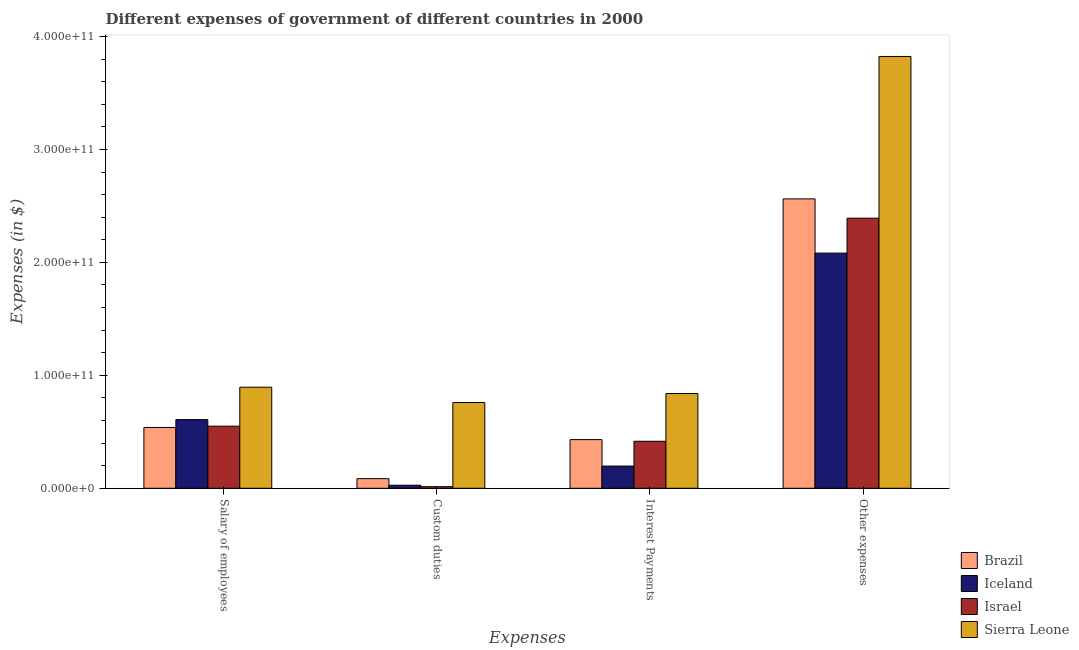How many different coloured bars are there?
Your answer should be very brief. 4. Are the number of bars per tick equal to the number of legend labels?
Ensure brevity in your answer.  Yes. How many bars are there on the 3rd tick from the right?
Make the answer very short. 4. What is the label of the 4th group of bars from the left?
Offer a very short reply. Other expenses. What is the amount spent on other expenses in Brazil?
Give a very brief answer. 2.56e+11. Across all countries, what is the maximum amount spent on custom duties?
Give a very brief answer. 7.59e+1. Across all countries, what is the minimum amount spent on other expenses?
Provide a short and direct response. 2.08e+11. In which country was the amount spent on custom duties maximum?
Ensure brevity in your answer.  Sierra Leone. In which country was the amount spent on other expenses minimum?
Your answer should be very brief. Iceland. What is the total amount spent on interest payments in the graph?
Keep it short and to the point. 1.88e+11. What is the difference between the amount spent on salary of employees in Sierra Leone and that in Israel?
Your answer should be very brief. 3.45e+1. What is the difference between the amount spent on custom duties in Iceland and the amount spent on other expenses in Brazil?
Ensure brevity in your answer.  -2.54e+11. What is the average amount spent on custom duties per country?
Provide a succinct answer. 2.21e+1. What is the difference between the amount spent on interest payments and amount spent on custom duties in Israel?
Offer a terse response. 4.02e+1. In how many countries, is the amount spent on salary of employees greater than 200000000000 $?
Offer a very short reply. 0. What is the ratio of the amount spent on other expenses in Brazil to that in Israel?
Give a very brief answer. 1.07. Is the difference between the amount spent on interest payments in Israel and Iceland greater than the difference between the amount spent on salary of employees in Israel and Iceland?
Your answer should be very brief. Yes. What is the difference between the highest and the second highest amount spent on other expenses?
Give a very brief answer. 1.26e+11. What is the difference between the highest and the lowest amount spent on interest payments?
Offer a very short reply. 6.42e+1. In how many countries, is the amount spent on other expenses greater than the average amount spent on other expenses taken over all countries?
Keep it short and to the point. 1. Is it the case that in every country, the sum of the amount spent on custom duties and amount spent on salary of employees is greater than the sum of amount spent on other expenses and amount spent on interest payments?
Offer a terse response. No. What does the 4th bar from the left in Other expenses represents?
Your response must be concise. Sierra Leone. What does the 1st bar from the right in Interest Payments represents?
Provide a short and direct response. Sierra Leone. How many bars are there?
Provide a succinct answer. 16. What is the difference between two consecutive major ticks on the Y-axis?
Provide a short and direct response. 1.00e+11. Are the values on the major ticks of Y-axis written in scientific E-notation?
Provide a short and direct response. Yes. What is the title of the graph?
Your answer should be very brief. Different expenses of government of different countries in 2000. Does "Hungary" appear as one of the legend labels in the graph?
Offer a terse response. No. What is the label or title of the X-axis?
Provide a succinct answer. Expenses. What is the label or title of the Y-axis?
Your answer should be compact. Expenses (in $). What is the Expenses (in $) in Brazil in Salary of employees?
Ensure brevity in your answer.  5.39e+1. What is the Expenses (in $) of Iceland in Salary of employees?
Your answer should be compact. 6.08e+1. What is the Expenses (in $) in Israel in Salary of employees?
Your answer should be very brief. 5.50e+1. What is the Expenses (in $) in Sierra Leone in Salary of employees?
Offer a terse response. 8.95e+1. What is the Expenses (in $) in Brazil in Custom duties?
Your answer should be compact. 8.51e+09. What is the Expenses (in $) in Iceland in Custom duties?
Your answer should be compact. 2.70e+09. What is the Expenses (in $) in Israel in Custom duties?
Your answer should be compact. 1.42e+09. What is the Expenses (in $) in Sierra Leone in Custom duties?
Give a very brief answer. 7.59e+1. What is the Expenses (in $) in Brazil in Interest Payments?
Offer a very short reply. 4.31e+1. What is the Expenses (in $) in Iceland in Interest Payments?
Offer a very short reply. 1.97e+1. What is the Expenses (in $) in Israel in Interest Payments?
Your response must be concise. 4.16e+1. What is the Expenses (in $) of Sierra Leone in Interest Payments?
Offer a terse response. 8.39e+1. What is the Expenses (in $) in Brazil in Other expenses?
Your answer should be very brief. 2.56e+11. What is the Expenses (in $) in Iceland in Other expenses?
Give a very brief answer. 2.08e+11. What is the Expenses (in $) in Israel in Other expenses?
Give a very brief answer. 2.39e+11. What is the Expenses (in $) of Sierra Leone in Other expenses?
Your answer should be very brief. 3.82e+11. Across all Expenses, what is the maximum Expenses (in $) of Brazil?
Your response must be concise. 2.56e+11. Across all Expenses, what is the maximum Expenses (in $) in Iceland?
Provide a short and direct response. 2.08e+11. Across all Expenses, what is the maximum Expenses (in $) of Israel?
Your answer should be compact. 2.39e+11. Across all Expenses, what is the maximum Expenses (in $) of Sierra Leone?
Give a very brief answer. 3.82e+11. Across all Expenses, what is the minimum Expenses (in $) in Brazil?
Ensure brevity in your answer.  8.51e+09. Across all Expenses, what is the minimum Expenses (in $) of Iceland?
Your answer should be very brief. 2.70e+09. Across all Expenses, what is the minimum Expenses (in $) of Israel?
Offer a terse response. 1.42e+09. Across all Expenses, what is the minimum Expenses (in $) in Sierra Leone?
Your answer should be very brief. 7.59e+1. What is the total Expenses (in $) of Brazil in the graph?
Ensure brevity in your answer.  3.62e+11. What is the total Expenses (in $) of Iceland in the graph?
Give a very brief answer. 2.91e+11. What is the total Expenses (in $) of Israel in the graph?
Provide a succinct answer. 3.37e+11. What is the total Expenses (in $) in Sierra Leone in the graph?
Your response must be concise. 6.32e+11. What is the difference between the Expenses (in $) in Brazil in Salary of employees and that in Custom duties?
Offer a very short reply. 4.53e+1. What is the difference between the Expenses (in $) in Iceland in Salary of employees and that in Custom duties?
Provide a succinct answer. 5.81e+1. What is the difference between the Expenses (in $) of Israel in Salary of employees and that in Custom duties?
Offer a very short reply. 5.36e+1. What is the difference between the Expenses (in $) of Sierra Leone in Salary of employees and that in Custom duties?
Ensure brevity in your answer.  1.36e+1. What is the difference between the Expenses (in $) in Brazil in Salary of employees and that in Interest Payments?
Provide a short and direct response. 1.08e+1. What is the difference between the Expenses (in $) in Iceland in Salary of employees and that in Interest Payments?
Make the answer very short. 4.11e+1. What is the difference between the Expenses (in $) in Israel in Salary of employees and that in Interest Payments?
Make the answer very short. 1.34e+1. What is the difference between the Expenses (in $) in Sierra Leone in Salary of employees and that in Interest Payments?
Provide a short and direct response. 5.58e+09. What is the difference between the Expenses (in $) in Brazil in Salary of employees and that in Other expenses?
Keep it short and to the point. -2.02e+11. What is the difference between the Expenses (in $) in Iceland in Salary of employees and that in Other expenses?
Give a very brief answer. -1.47e+11. What is the difference between the Expenses (in $) in Israel in Salary of employees and that in Other expenses?
Offer a terse response. -1.84e+11. What is the difference between the Expenses (in $) in Sierra Leone in Salary of employees and that in Other expenses?
Provide a succinct answer. -2.93e+11. What is the difference between the Expenses (in $) of Brazil in Custom duties and that in Interest Payments?
Make the answer very short. -3.46e+1. What is the difference between the Expenses (in $) of Iceland in Custom duties and that in Interest Payments?
Make the answer very short. -1.70e+1. What is the difference between the Expenses (in $) of Israel in Custom duties and that in Interest Payments?
Provide a short and direct response. -4.02e+1. What is the difference between the Expenses (in $) in Sierra Leone in Custom duties and that in Interest Payments?
Your response must be concise. -8.00e+09. What is the difference between the Expenses (in $) in Brazil in Custom duties and that in Other expenses?
Your answer should be very brief. -2.48e+11. What is the difference between the Expenses (in $) in Iceland in Custom duties and that in Other expenses?
Make the answer very short. -2.06e+11. What is the difference between the Expenses (in $) of Israel in Custom duties and that in Other expenses?
Offer a very short reply. -2.38e+11. What is the difference between the Expenses (in $) of Sierra Leone in Custom duties and that in Other expenses?
Give a very brief answer. -3.06e+11. What is the difference between the Expenses (in $) of Brazil in Interest Payments and that in Other expenses?
Provide a short and direct response. -2.13e+11. What is the difference between the Expenses (in $) in Iceland in Interest Payments and that in Other expenses?
Provide a succinct answer. -1.89e+11. What is the difference between the Expenses (in $) of Israel in Interest Payments and that in Other expenses?
Provide a succinct answer. -1.98e+11. What is the difference between the Expenses (in $) of Sierra Leone in Interest Payments and that in Other expenses?
Your response must be concise. -2.98e+11. What is the difference between the Expenses (in $) in Brazil in Salary of employees and the Expenses (in $) in Iceland in Custom duties?
Offer a terse response. 5.12e+1. What is the difference between the Expenses (in $) in Brazil in Salary of employees and the Expenses (in $) in Israel in Custom duties?
Keep it short and to the point. 5.24e+1. What is the difference between the Expenses (in $) of Brazil in Salary of employees and the Expenses (in $) of Sierra Leone in Custom duties?
Give a very brief answer. -2.21e+1. What is the difference between the Expenses (in $) of Iceland in Salary of employees and the Expenses (in $) of Israel in Custom duties?
Keep it short and to the point. 5.94e+1. What is the difference between the Expenses (in $) in Iceland in Salary of employees and the Expenses (in $) in Sierra Leone in Custom duties?
Make the answer very short. -1.51e+1. What is the difference between the Expenses (in $) of Israel in Salary of employees and the Expenses (in $) of Sierra Leone in Custom duties?
Your answer should be compact. -2.09e+1. What is the difference between the Expenses (in $) of Brazil in Salary of employees and the Expenses (in $) of Iceland in Interest Payments?
Offer a very short reply. 3.42e+1. What is the difference between the Expenses (in $) of Brazil in Salary of employees and the Expenses (in $) of Israel in Interest Payments?
Offer a very short reply. 1.22e+1. What is the difference between the Expenses (in $) in Brazil in Salary of employees and the Expenses (in $) in Sierra Leone in Interest Payments?
Keep it short and to the point. -3.01e+1. What is the difference between the Expenses (in $) in Iceland in Salary of employees and the Expenses (in $) in Israel in Interest Payments?
Your answer should be very brief. 1.92e+1. What is the difference between the Expenses (in $) of Iceland in Salary of employees and the Expenses (in $) of Sierra Leone in Interest Payments?
Offer a very short reply. -2.31e+1. What is the difference between the Expenses (in $) in Israel in Salary of employees and the Expenses (in $) in Sierra Leone in Interest Payments?
Make the answer very short. -2.89e+1. What is the difference between the Expenses (in $) in Brazil in Salary of employees and the Expenses (in $) in Iceland in Other expenses?
Give a very brief answer. -1.54e+11. What is the difference between the Expenses (in $) of Brazil in Salary of employees and the Expenses (in $) of Israel in Other expenses?
Make the answer very short. -1.85e+11. What is the difference between the Expenses (in $) in Brazil in Salary of employees and the Expenses (in $) in Sierra Leone in Other expenses?
Offer a very short reply. -3.28e+11. What is the difference between the Expenses (in $) in Iceland in Salary of employees and the Expenses (in $) in Israel in Other expenses?
Provide a short and direct response. -1.78e+11. What is the difference between the Expenses (in $) of Iceland in Salary of employees and the Expenses (in $) of Sierra Leone in Other expenses?
Your response must be concise. -3.22e+11. What is the difference between the Expenses (in $) of Israel in Salary of employees and the Expenses (in $) of Sierra Leone in Other expenses?
Make the answer very short. -3.27e+11. What is the difference between the Expenses (in $) in Brazil in Custom duties and the Expenses (in $) in Iceland in Interest Payments?
Give a very brief answer. -1.12e+1. What is the difference between the Expenses (in $) in Brazil in Custom duties and the Expenses (in $) in Israel in Interest Payments?
Offer a terse response. -3.31e+1. What is the difference between the Expenses (in $) of Brazil in Custom duties and the Expenses (in $) of Sierra Leone in Interest Payments?
Keep it short and to the point. -7.54e+1. What is the difference between the Expenses (in $) of Iceland in Custom duties and the Expenses (in $) of Israel in Interest Payments?
Ensure brevity in your answer.  -3.89e+1. What is the difference between the Expenses (in $) of Iceland in Custom duties and the Expenses (in $) of Sierra Leone in Interest Payments?
Your answer should be very brief. -8.12e+1. What is the difference between the Expenses (in $) in Israel in Custom duties and the Expenses (in $) in Sierra Leone in Interest Payments?
Your response must be concise. -8.25e+1. What is the difference between the Expenses (in $) in Brazil in Custom duties and the Expenses (in $) in Iceland in Other expenses?
Your answer should be compact. -2.00e+11. What is the difference between the Expenses (in $) of Brazil in Custom duties and the Expenses (in $) of Israel in Other expenses?
Your answer should be very brief. -2.31e+11. What is the difference between the Expenses (in $) in Brazil in Custom duties and the Expenses (in $) in Sierra Leone in Other expenses?
Provide a short and direct response. -3.74e+11. What is the difference between the Expenses (in $) of Iceland in Custom duties and the Expenses (in $) of Israel in Other expenses?
Offer a very short reply. -2.36e+11. What is the difference between the Expenses (in $) of Iceland in Custom duties and the Expenses (in $) of Sierra Leone in Other expenses?
Your answer should be very brief. -3.80e+11. What is the difference between the Expenses (in $) in Israel in Custom duties and the Expenses (in $) in Sierra Leone in Other expenses?
Give a very brief answer. -3.81e+11. What is the difference between the Expenses (in $) in Brazil in Interest Payments and the Expenses (in $) in Iceland in Other expenses?
Your answer should be very brief. -1.65e+11. What is the difference between the Expenses (in $) of Brazil in Interest Payments and the Expenses (in $) of Israel in Other expenses?
Your response must be concise. -1.96e+11. What is the difference between the Expenses (in $) in Brazil in Interest Payments and the Expenses (in $) in Sierra Leone in Other expenses?
Offer a terse response. -3.39e+11. What is the difference between the Expenses (in $) in Iceland in Interest Payments and the Expenses (in $) in Israel in Other expenses?
Provide a short and direct response. -2.19e+11. What is the difference between the Expenses (in $) in Iceland in Interest Payments and the Expenses (in $) in Sierra Leone in Other expenses?
Give a very brief answer. -3.63e+11. What is the difference between the Expenses (in $) in Israel in Interest Payments and the Expenses (in $) in Sierra Leone in Other expenses?
Ensure brevity in your answer.  -3.41e+11. What is the average Expenses (in $) of Brazil per Expenses?
Your answer should be very brief. 9.04e+1. What is the average Expenses (in $) in Iceland per Expenses?
Give a very brief answer. 7.28e+1. What is the average Expenses (in $) of Israel per Expenses?
Your response must be concise. 8.43e+1. What is the average Expenses (in $) in Sierra Leone per Expenses?
Ensure brevity in your answer.  1.58e+11. What is the difference between the Expenses (in $) of Brazil and Expenses (in $) of Iceland in Salary of employees?
Make the answer very short. -6.95e+09. What is the difference between the Expenses (in $) of Brazil and Expenses (in $) of Israel in Salary of employees?
Your answer should be very brief. -1.14e+09. What is the difference between the Expenses (in $) of Brazil and Expenses (in $) of Sierra Leone in Salary of employees?
Give a very brief answer. -3.56e+1. What is the difference between the Expenses (in $) in Iceland and Expenses (in $) in Israel in Salary of employees?
Offer a very short reply. 5.81e+09. What is the difference between the Expenses (in $) in Iceland and Expenses (in $) in Sierra Leone in Salary of employees?
Your answer should be very brief. -2.87e+1. What is the difference between the Expenses (in $) of Israel and Expenses (in $) of Sierra Leone in Salary of employees?
Offer a terse response. -3.45e+1. What is the difference between the Expenses (in $) of Brazil and Expenses (in $) of Iceland in Custom duties?
Offer a very short reply. 5.81e+09. What is the difference between the Expenses (in $) in Brazil and Expenses (in $) in Israel in Custom duties?
Provide a short and direct response. 7.09e+09. What is the difference between the Expenses (in $) in Brazil and Expenses (in $) in Sierra Leone in Custom duties?
Give a very brief answer. -6.74e+1. What is the difference between the Expenses (in $) in Iceland and Expenses (in $) in Israel in Custom duties?
Offer a terse response. 1.28e+09. What is the difference between the Expenses (in $) of Iceland and Expenses (in $) of Sierra Leone in Custom duties?
Give a very brief answer. -7.32e+1. What is the difference between the Expenses (in $) in Israel and Expenses (in $) in Sierra Leone in Custom duties?
Your response must be concise. -7.45e+1. What is the difference between the Expenses (in $) of Brazil and Expenses (in $) of Iceland in Interest Payments?
Your answer should be very brief. 2.34e+1. What is the difference between the Expenses (in $) of Brazil and Expenses (in $) of Israel in Interest Payments?
Your response must be concise. 1.47e+09. What is the difference between the Expenses (in $) of Brazil and Expenses (in $) of Sierra Leone in Interest Payments?
Provide a succinct answer. -4.08e+1. What is the difference between the Expenses (in $) in Iceland and Expenses (in $) in Israel in Interest Payments?
Keep it short and to the point. -2.20e+1. What is the difference between the Expenses (in $) in Iceland and Expenses (in $) in Sierra Leone in Interest Payments?
Provide a succinct answer. -6.42e+1. What is the difference between the Expenses (in $) in Israel and Expenses (in $) in Sierra Leone in Interest Payments?
Your answer should be very brief. -4.23e+1. What is the difference between the Expenses (in $) in Brazil and Expenses (in $) in Iceland in Other expenses?
Provide a short and direct response. 4.80e+1. What is the difference between the Expenses (in $) in Brazil and Expenses (in $) in Israel in Other expenses?
Keep it short and to the point. 1.71e+1. What is the difference between the Expenses (in $) in Brazil and Expenses (in $) in Sierra Leone in Other expenses?
Your answer should be very brief. -1.26e+11. What is the difference between the Expenses (in $) of Iceland and Expenses (in $) of Israel in Other expenses?
Keep it short and to the point. -3.09e+1. What is the difference between the Expenses (in $) in Iceland and Expenses (in $) in Sierra Leone in Other expenses?
Your answer should be compact. -1.74e+11. What is the difference between the Expenses (in $) in Israel and Expenses (in $) in Sierra Leone in Other expenses?
Keep it short and to the point. -1.43e+11. What is the ratio of the Expenses (in $) of Brazil in Salary of employees to that in Custom duties?
Ensure brevity in your answer.  6.33. What is the ratio of the Expenses (in $) of Iceland in Salary of employees to that in Custom duties?
Your response must be concise. 22.52. What is the ratio of the Expenses (in $) in Israel in Salary of employees to that in Custom duties?
Your answer should be compact. 38.81. What is the ratio of the Expenses (in $) in Sierra Leone in Salary of employees to that in Custom duties?
Provide a succinct answer. 1.18. What is the ratio of the Expenses (in $) in Brazil in Salary of employees to that in Interest Payments?
Make the answer very short. 1.25. What is the ratio of the Expenses (in $) in Iceland in Salary of employees to that in Interest Payments?
Offer a very short reply. 3.09. What is the ratio of the Expenses (in $) of Israel in Salary of employees to that in Interest Payments?
Give a very brief answer. 1.32. What is the ratio of the Expenses (in $) in Sierra Leone in Salary of employees to that in Interest Payments?
Offer a terse response. 1.07. What is the ratio of the Expenses (in $) of Brazil in Salary of employees to that in Other expenses?
Your answer should be very brief. 0.21. What is the ratio of the Expenses (in $) in Iceland in Salary of employees to that in Other expenses?
Your answer should be very brief. 0.29. What is the ratio of the Expenses (in $) in Israel in Salary of employees to that in Other expenses?
Give a very brief answer. 0.23. What is the ratio of the Expenses (in $) of Sierra Leone in Salary of employees to that in Other expenses?
Offer a very short reply. 0.23. What is the ratio of the Expenses (in $) of Brazil in Custom duties to that in Interest Payments?
Provide a succinct answer. 0.2. What is the ratio of the Expenses (in $) in Iceland in Custom duties to that in Interest Payments?
Keep it short and to the point. 0.14. What is the ratio of the Expenses (in $) of Israel in Custom duties to that in Interest Payments?
Make the answer very short. 0.03. What is the ratio of the Expenses (in $) in Sierra Leone in Custom duties to that in Interest Payments?
Make the answer very short. 0.9. What is the ratio of the Expenses (in $) in Brazil in Custom duties to that in Other expenses?
Provide a short and direct response. 0.03. What is the ratio of the Expenses (in $) of Iceland in Custom duties to that in Other expenses?
Offer a terse response. 0.01. What is the ratio of the Expenses (in $) in Israel in Custom duties to that in Other expenses?
Provide a short and direct response. 0.01. What is the ratio of the Expenses (in $) of Sierra Leone in Custom duties to that in Other expenses?
Your answer should be very brief. 0.2. What is the ratio of the Expenses (in $) of Brazil in Interest Payments to that in Other expenses?
Ensure brevity in your answer.  0.17. What is the ratio of the Expenses (in $) of Iceland in Interest Payments to that in Other expenses?
Your answer should be very brief. 0.09. What is the ratio of the Expenses (in $) in Israel in Interest Payments to that in Other expenses?
Provide a succinct answer. 0.17. What is the ratio of the Expenses (in $) in Sierra Leone in Interest Payments to that in Other expenses?
Keep it short and to the point. 0.22. What is the difference between the highest and the second highest Expenses (in $) in Brazil?
Keep it short and to the point. 2.02e+11. What is the difference between the highest and the second highest Expenses (in $) in Iceland?
Offer a terse response. 1.47e+11. What is the difference between the highest and the second highest Expenses (in $) in Israel?
Ensure brevity in your answer.  1.84e+11. What is the difference between the highest and the second highest Expenses (in $) in Sierra Leone?
Ensure brevity in your answer.  2.93e+11. What is the difference between the highest and the lowest Expenses (in $) of Brazil?
Your response must be concise. 2.48e+11. What is the difference between the highest and the lowest Expenses (in $) of Iceland?
Your answer should be compact. 2.06e+11. What is the difference between the highest and the lowest Expenses (in $) in Israel?
Offer a terse response. 2.38e+11. What is the difference between the highest and the lowest Expenses (in $) of Sierra Leone?
Provide a short and direct response. 3.06e+11. 